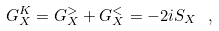<formula> <loc_0><loc_0><loc_500><loc_500>G _ { X } ^ { K } = G _ { X } ^ { > } + G _ { X } ^ { < } = - 2 i S _ { X } \ ,</formula> 